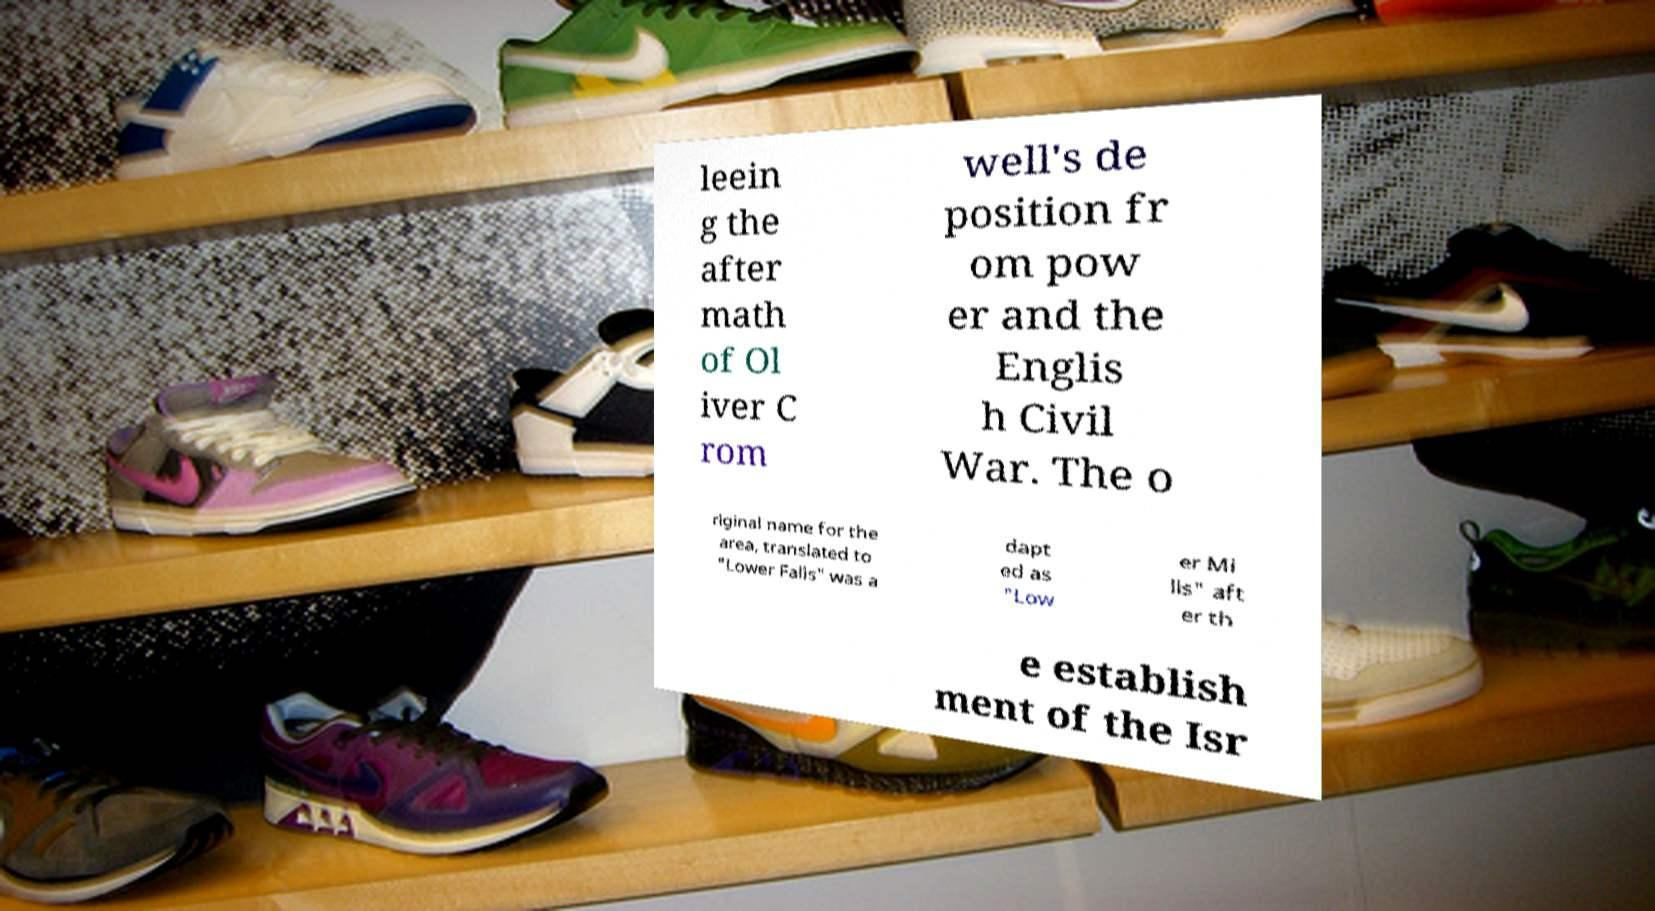Please identify and transcribe the text found in this image. leein g the after math of Ol iver C rom well's de position fr om pow er and the Englis h Civil War. The o riginal name for the area, translated to "Lower Falls" was a dapt ed as "Low er Mi lls" aft er th e establish ment of the Isr 